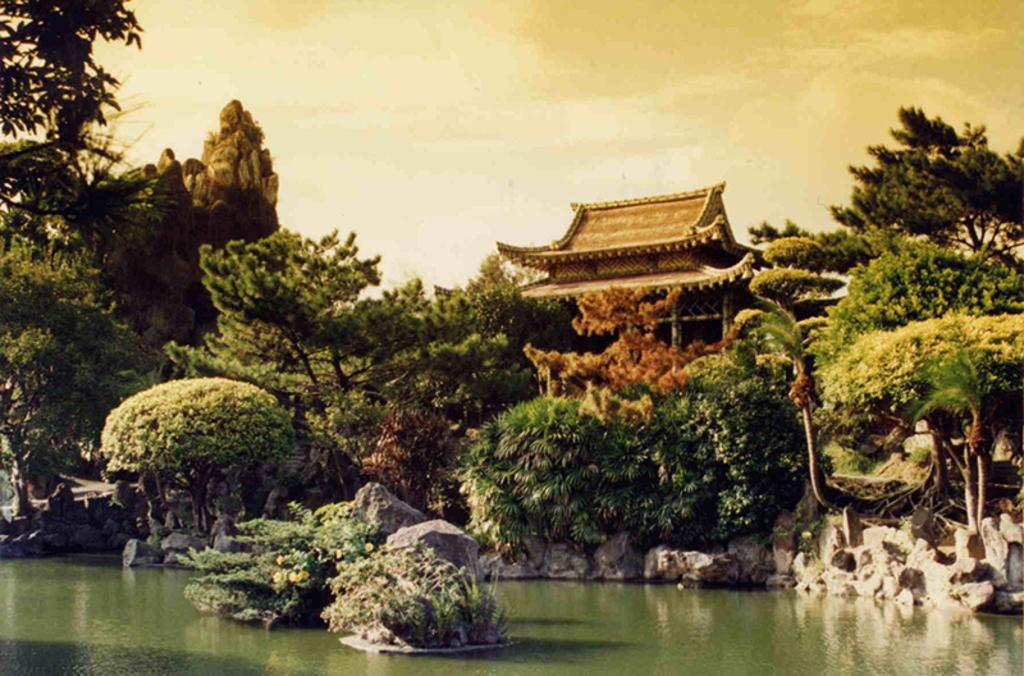What type of artwork is depicted in the image? The image is a painting. What natural feature can be seen in the painting? There is a lake in the painting. What type of vegetation is near the lake in the painting? There are plants beside the lake in the painting. What type of structure is present in the painting? There is a shed in the painting. What type of appliance can be seen floating on the lake in the painting? There is no appliance present in the painting; it only features a lake, plants, and a shed. 